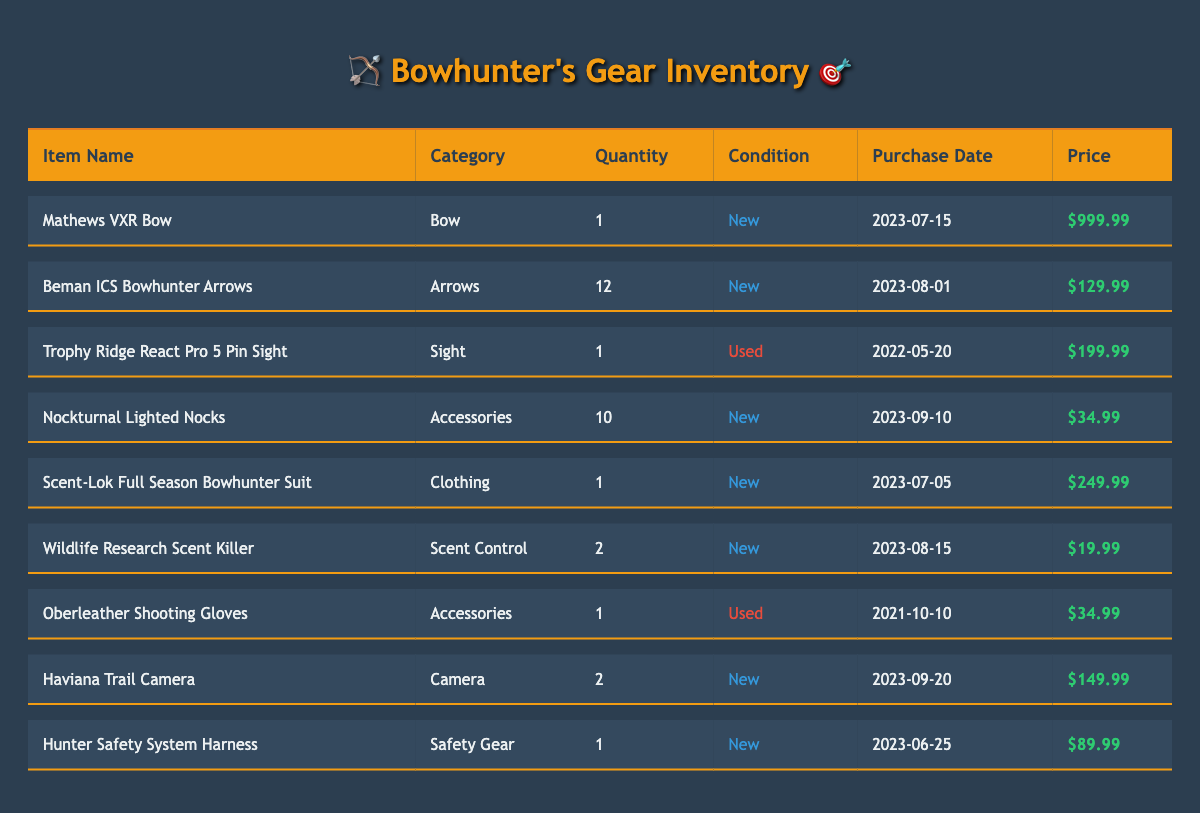What is the total quantity of arrows in the inventory? There are 12 Beman ICS Bowhunter Arrows listed under the Arrows category, and no other arrow items are present in the inventory. So, the total quantity of arrows is simply 12.
Answer: 12 How many new items are in the inventory? By reviewing the table, I count the items marked as "New." These are the Mathews VXR Bow, Beman ICS Bowhunter Arrows, Nockturnal Lighted Nocks, Scent-Lok Full Season Bowhunter Suit, Wildlife Research Scent Killer, Haviana Trail Camera, and Hunter Safety System Harness. That gives us a total of 7 new items.
Answer: 7 What is the total cost of the used items? There are two used items: Trophy Ridge React Pro 5 Pin Sight costing $199.99 and Oberleather Shooting Gloves costing $34.99. Their total cost can be calculated by adding these amounts: 199.99 + 34.99 = $234.98.
Answer: 234.98 Does the inventory include any items priced over $500? I check the prices of the items in the table. The only item priced over $500 is the Mathews VXR Bow at $999.99. The inventory does contain an item over $500, thus the answer is yes.
Answer: Yes Which category has the highest quantity of items? The categories are: Bow (1), Arrows (12), Sight (1), Accessories (11), Clothing (1), Scent Control (2), Camera (2), and Safety Gear (1). The highest quantity is under the Arrows category with 12 items.
Answer: Arrows What is the average price of all items in the inventory? To find the average price, I first sum the prices of all the items: 999.99 + 129.99 + 199.99 + 34.99 + 249.99 + 19.99 + 34.99 + 149.99 + 89.99 = $1,898.92. There are 9 items, so the average price is 1898.92 / 9 = $210.99.
Answer: 210.99 Is there any item in the inventory that is both used and has a purchase date in 2022? The used items are the Trophy Ridge React Pro 5 Pin Sight purchased on 2022-05-20 and the Oberleather Shooting Gloves purchased on 2021-10-10. Since one of the used items was purchased in 2022, it confirms that yes, there is such an item.
Answer: Yes What is the total quantity of items in the accessories category? The table shows Nockturnal Lighted Nocks (10) and Oberleather Shooting Gloves (1) listed under accessories. Adding these quantities results in 10 + 1 = 11. Thus the total quantity of items in the accessories category is 11.
Answer: 11 What is the purchase date of the item with the highest price? The item with the highest price is the Mathews VXR Bow, priced at $999.99. According to the table, it was purchased on 2023-07-15.
Answer: 2023-07-15 